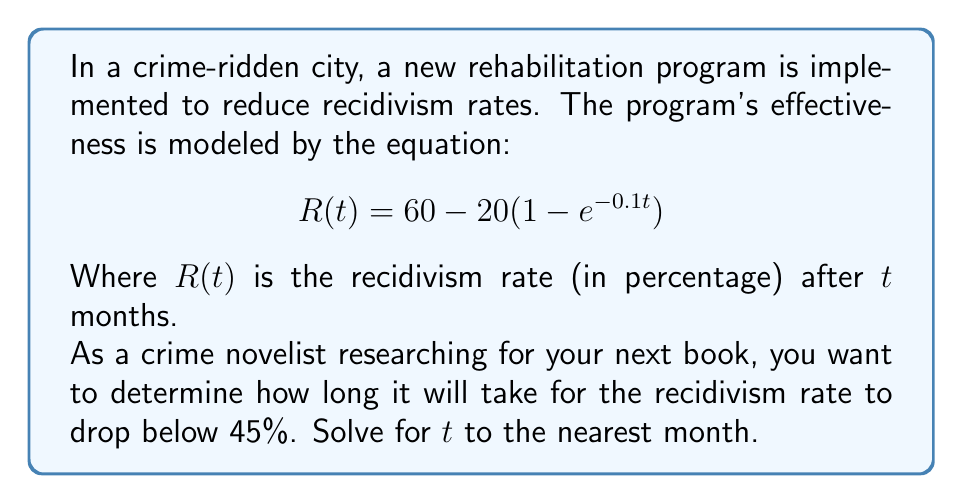What is the answer to this math problem? Let's approach this step-by-step:

1) We want to find $t$ when $R(t) = 45$. So, we set up the equation:

   $$45 = 60 - 20(1 - e^{-0.1t})$$

2) Subtract 60 from both sides:

   $$-15 = -20(1 - e^{-0.1t})$$

3) Divide both sides by -20:

   $$0.75 = 1 - e^{-0.1t}$$

4) Subtract 1 from both sides:

   $$-0.25 = -e^{-0.1t}$$

5) Multiply both sides by -1:

   $$0.25 = e^{-0.1t}$$

6) Take the natural log of both sides:

   $$\ln(0.25) = -0.1t$$

7) Divide both sides by -0.1:

   $$\frac{\ln(0.25)}{-0.1} = t$$

8) Calculate:

   $$t = \frac{\ln(0.25)}{-0.1} \approx 13.86$$

9) Rounding to the nearest month:

   $t \approx 14$ months
Answer: 14 months 